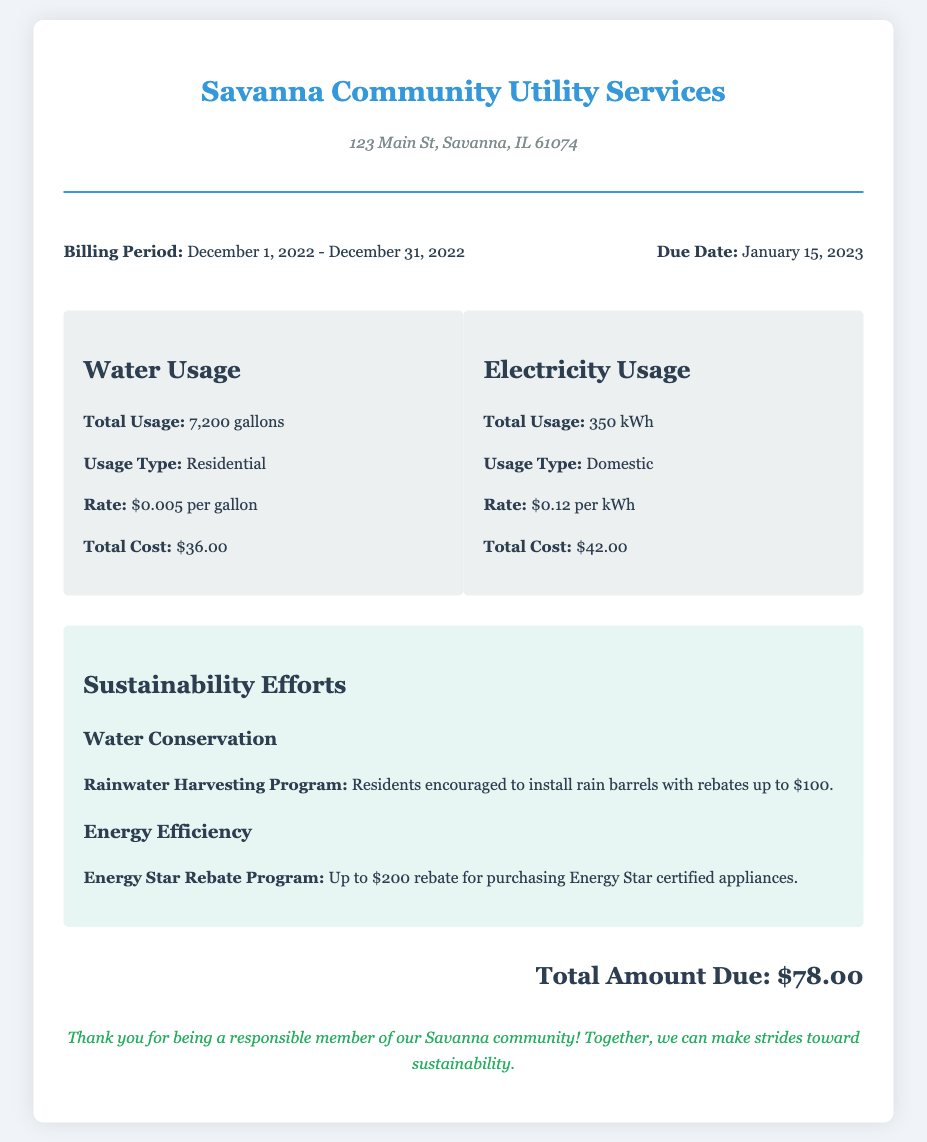What is the billing period? The billing period is indicated as from December 1, 2022, to December 31, 2022.
Answer: December 1, 2022 - December 31, 2022 What is the total water usage? The document specifies the total water usage as 7,200 gallons.
Answer: 7,200 gallons What is the total cost for electricity? The total cost for electricity is listed as $42.00.
Answer: $42.00 What is the due date for the bill? The document states that the due date for the bill is January 15, 2023.
Answer: January 15, 2023 What rebate is offered for rainwater harvesting? The document mentions that there are rebates up to $100 for rainwater harvesting.
Answer: $100 How much is the total amount due? The total amount due is explicitly stated in the document as $78.00.
Answer: $78.00 What energy efficiency program is mentioned? The document highlights the Energy Star Rebate Program as an initiative for energy efficiency.
Answer: Energy Star Rebate Program How many kilowatt-hours were used? The total electricity usage is provided as 350 kWh in the document.
Answer: 350 kWh What is the total cost for water? The document states the total cost for water usage as $36.00.
Answer: $36.00 